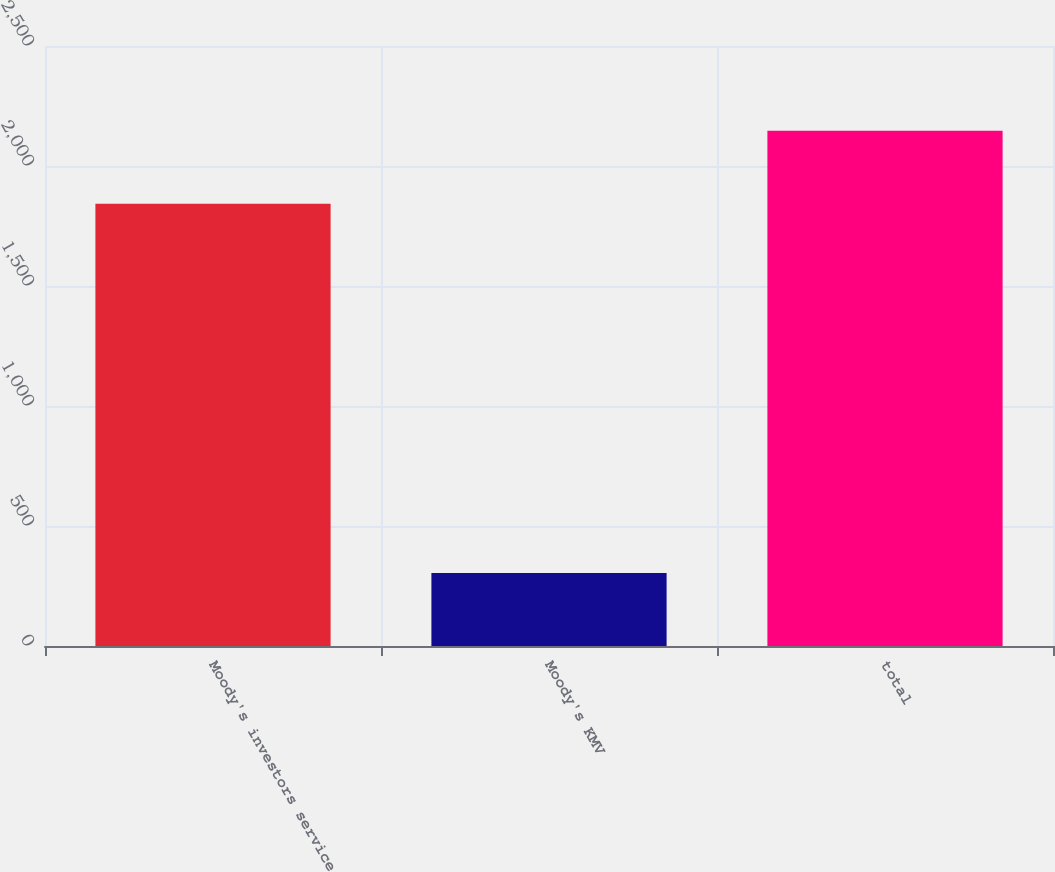Convert chart. <chart><loc_0><loc_0><loc_500><loc_500><bar_chart><fcel>Moody's investors service<fcel>Moody's KMV<fcel>total<nl><fcel>1843<fcel>304<fcel>2147<nl></chart> 